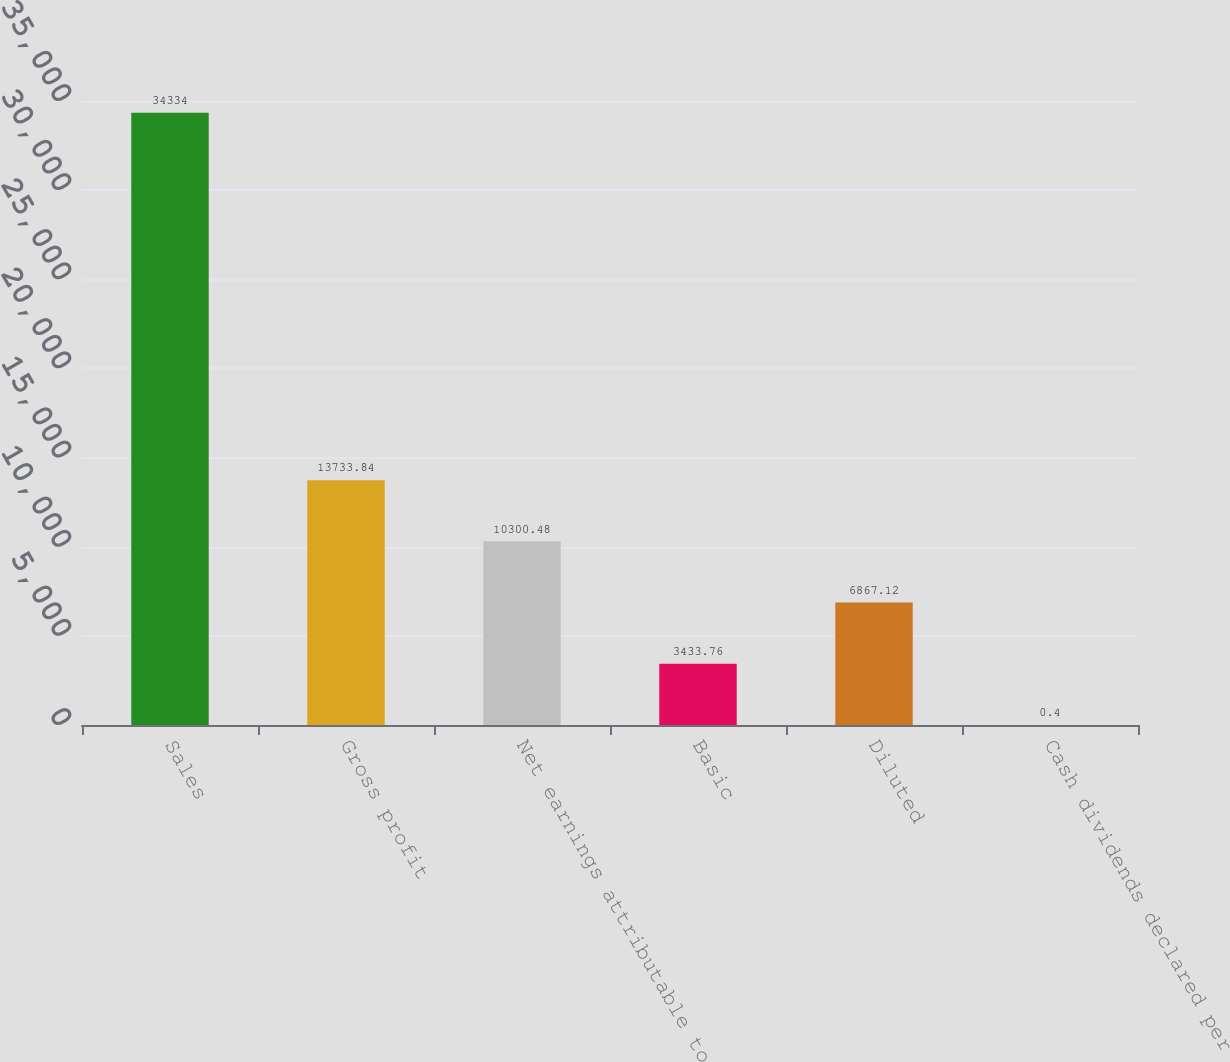Convert chart to OTSL. <chart><loc_0><loc_0><loc_500><loc_500><bar_chart><fcel>Sales<fcel>Gross profit<fcel>Net earnings attributable to<fcel>Basic<fcel>Diluted<fcel>Cash dividends declared per<nl><fcel>34334<fcel>13733.8<fcel>10300.5<fcel>3433.76<fcel>6867.12<fcel>0.4<nl></chart> 